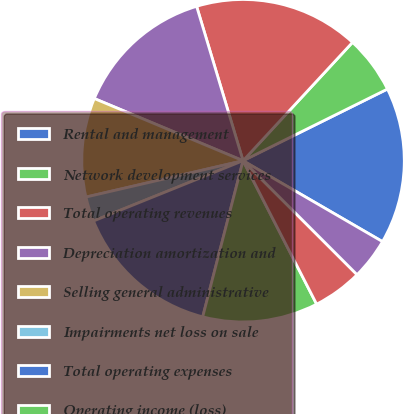Convert chart. <chart><loc_0><loc_0><loc_500><loc_500><pie_chart><fcel>Rental and management<fcel>Network development services<fcel>Total operating revenues<fcel>Depreciation amortization and<fcel>Selling general administrative<fcel>Impairments net loss on sale<fcel>Total operating expenses<fcel>Operating income (loss)<fcel>Interest income TV Azteca net<fcel>Interest income<nl><fcel>15.7%<fcel>5.79%<fcel>16.53%<fcel>14.05%<fcel>9.92%<fcel>2.48%<fcel>14.88%<fcel>11.57%<fcel>4.96%<fcel>4.13%<nl></chart> 